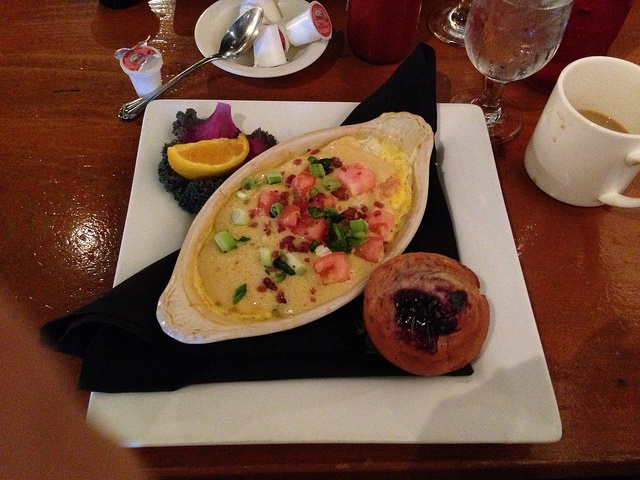Describe the objects in this image and their specific colors. I can see dining table in maroon, black, darkgray, and tan tones, bowl in maroon, tan, and olive tones, cup in maroon, tan, and gray tones, wine glass in maroon and brown tones, and bowl in maroon, darkgray, lavender, tan, and gray tones in this image. 